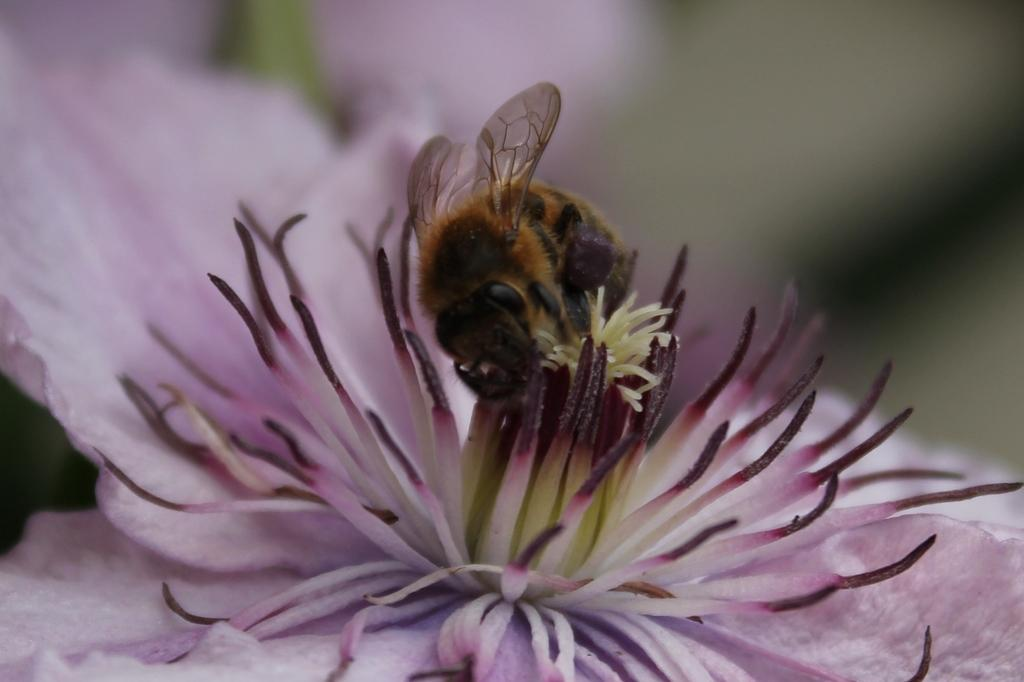What is the main subject of the image? There is an insect in the image. Where is the insect located? The insect is on a flower. Can you describe the background of the image? The background of the image is blurred. What type of apparatus is being used by the insect to extract the cork from the flower? There is no apparatus or cork present in the image; it features an insect on a flower with a blurred background. 